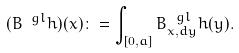Convert formula to latex. <formula><loc_0><loc_0><loc_500><loc_500>( B ^ { \ g l } h ) ( x ) \colon = \int _ { [ 0 , a ] } B _ { x , d y } ^ { \ g l } h ( y ) .</formula> 